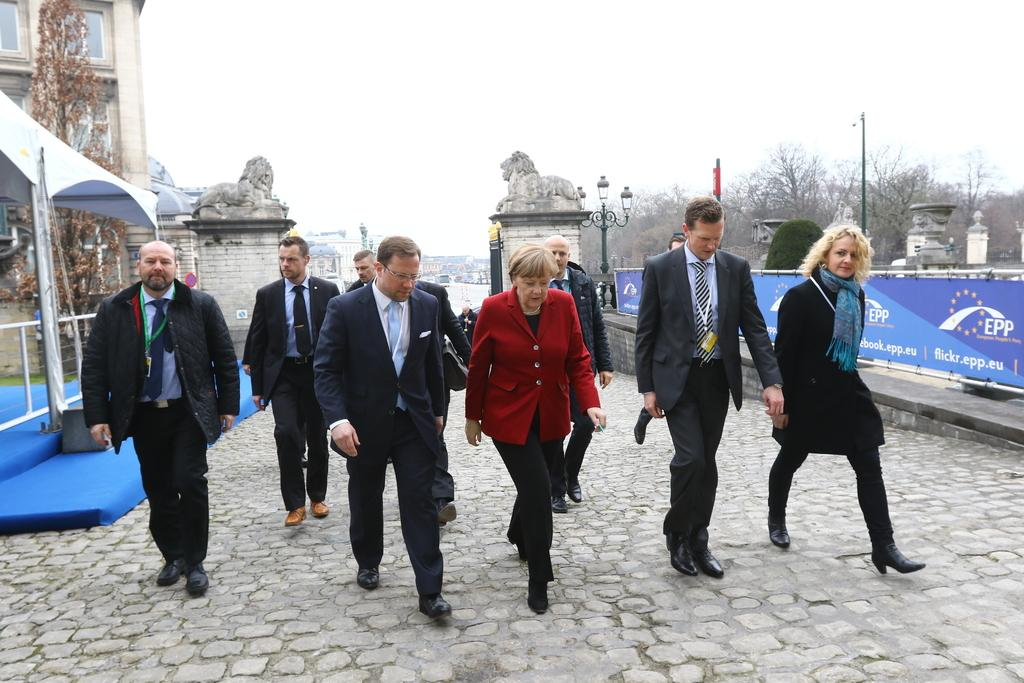What are the people in the image doing? The people in the image are walking on the road. What can be seen in the background of the image? There are buildings and trees visible in the image. What else is present in the image besides people and buildings? There are banners in the image. What type of paint is being used by the people in the image? There is no paint or painting activity present in the image. What can be heard in the image? The image is silent, so no sounds or hearing can be determined. 